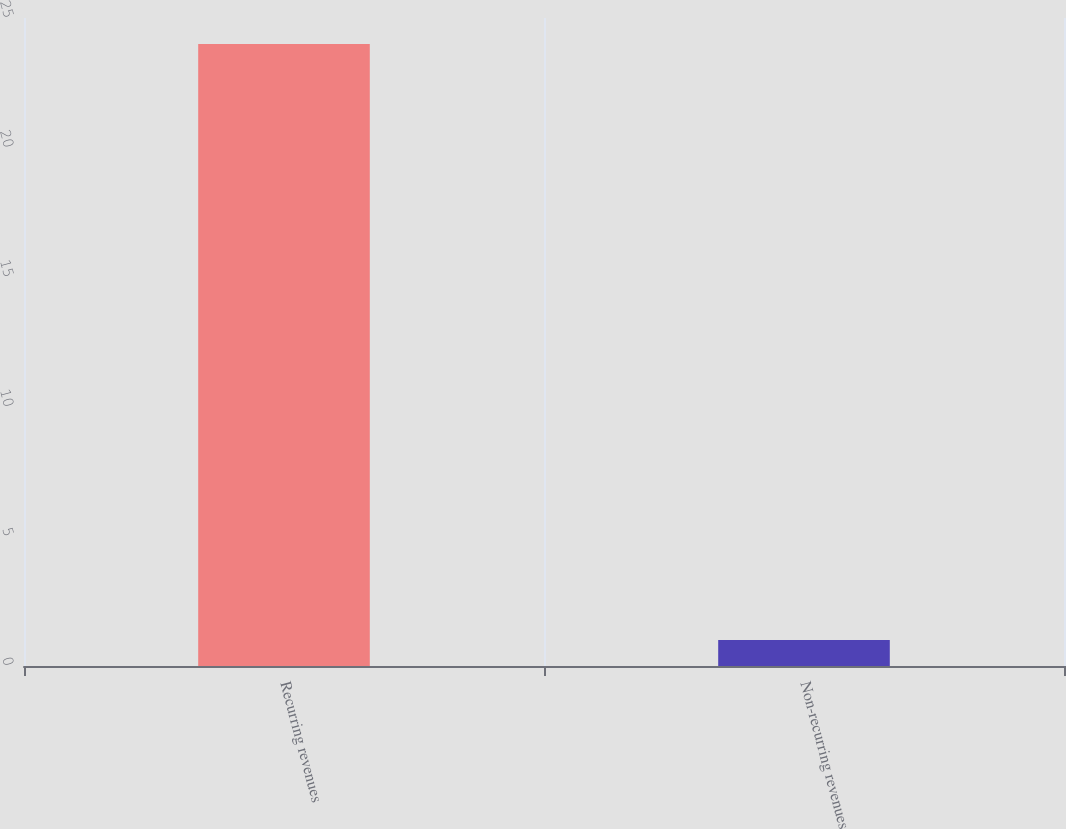<chart> <loc_0><loc_0><loc_500><loc_500><bar_chart><fcel>Recurring revenues<fcel>Non-recurring revenues<nl><fcel>24<fcel>1<nl></chart> 